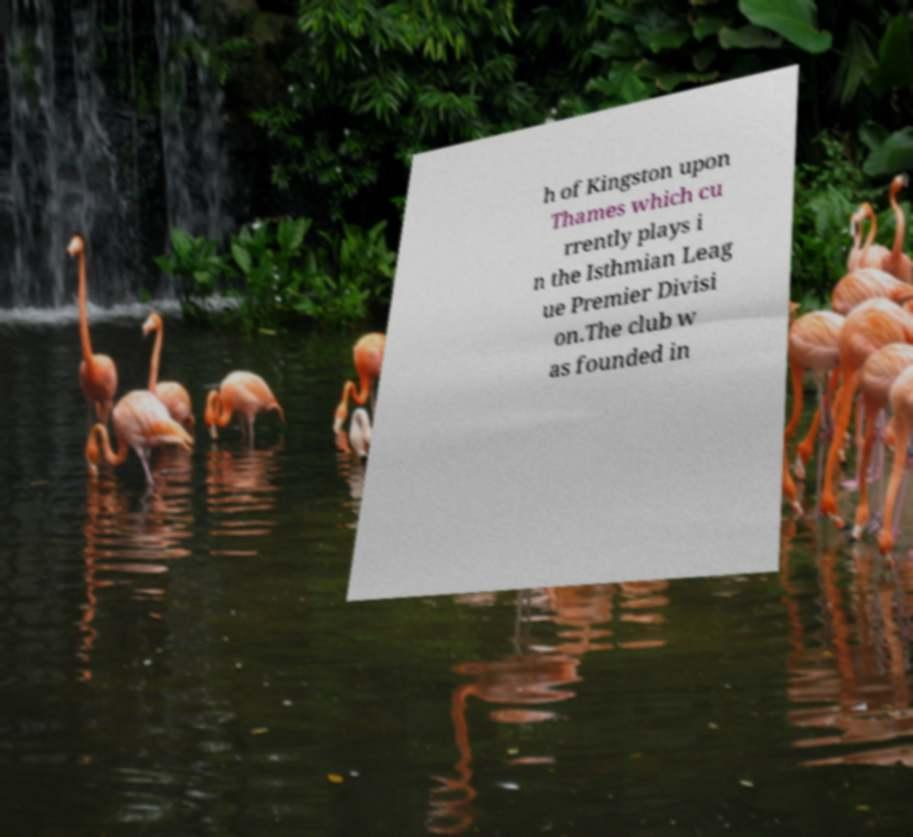Please read and relay the text visible in this image. What does it say? h of Kingston upon Thames which cu rrently plays i n the Isthmian Leag ue Premier Divisi on.The club w as founded in 